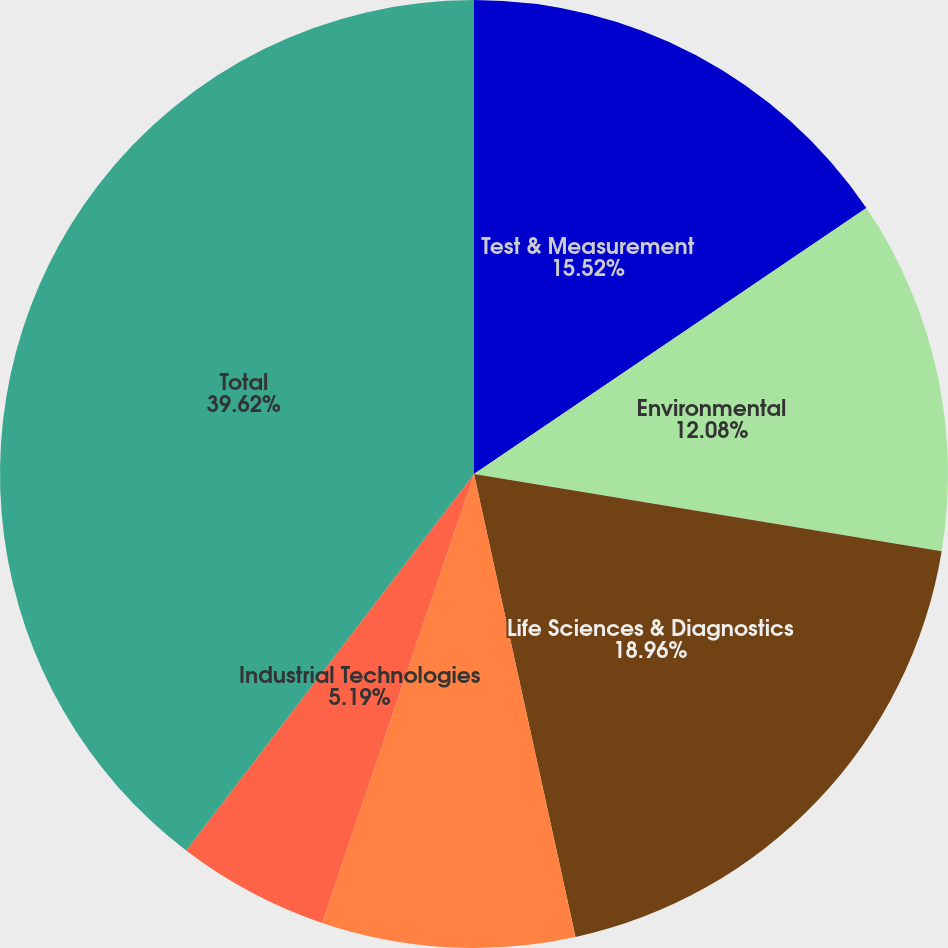<chart> <loc_0><loc_0><loc_500><loc_500><pie_chart><fcel>Test & Measurement<fcel>Environmental<fcel>Life Sciences & Diagnostics<fcel>Dental<fcel>Industrial Technologies<fcel>Total<nl><fcel>15.52%<fcel>12.08%<fcel>18.96%<fcel>8.63%<fcel>5.19%<fcel>39.61%<nl></chart> 